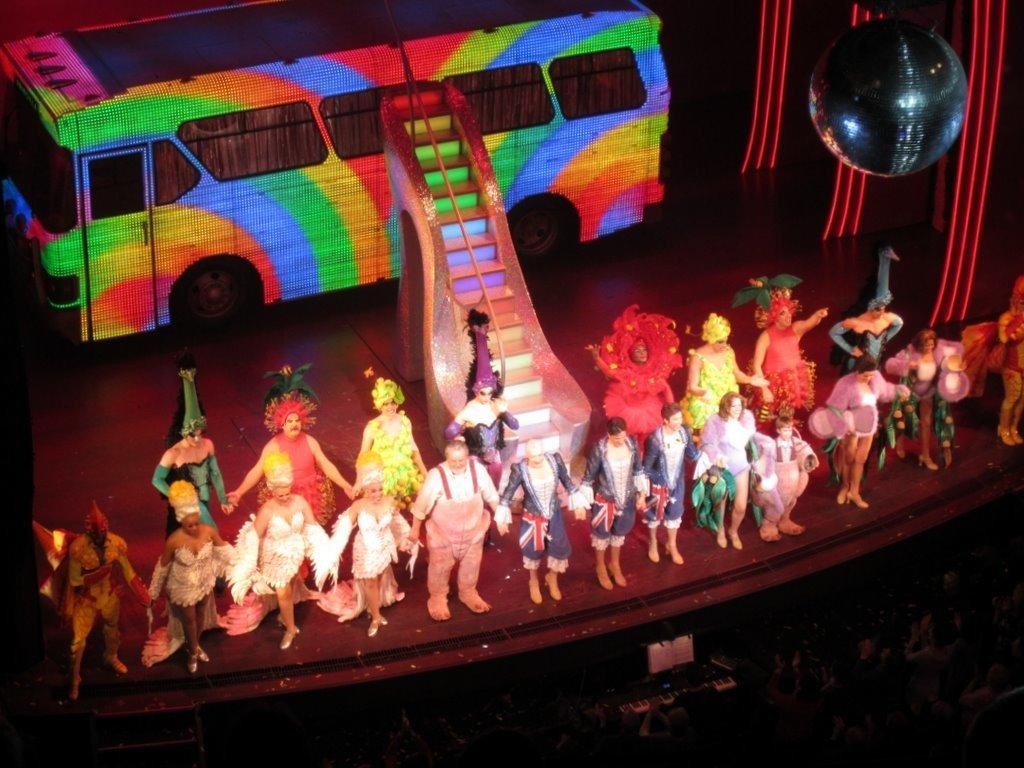What are the persons on the stage doing? The persons on the stage are holding hands. What can be seen in the background of the image? There is a bus in the image. Are there any architectural features in the image? Yes, there are steps in the image. What type of object is spherical in the image? There is a spherical object in the image, but it is not specified what it is. Who is present at the bottom of the image? There is an audience at the bottom of the image. What type of business is being conducted in the image? There is no indication of any business being conducted in the image. What fruit is being held by the persons on the stage? There is no fruit present in the image; the persons on the stage are holding hands. 